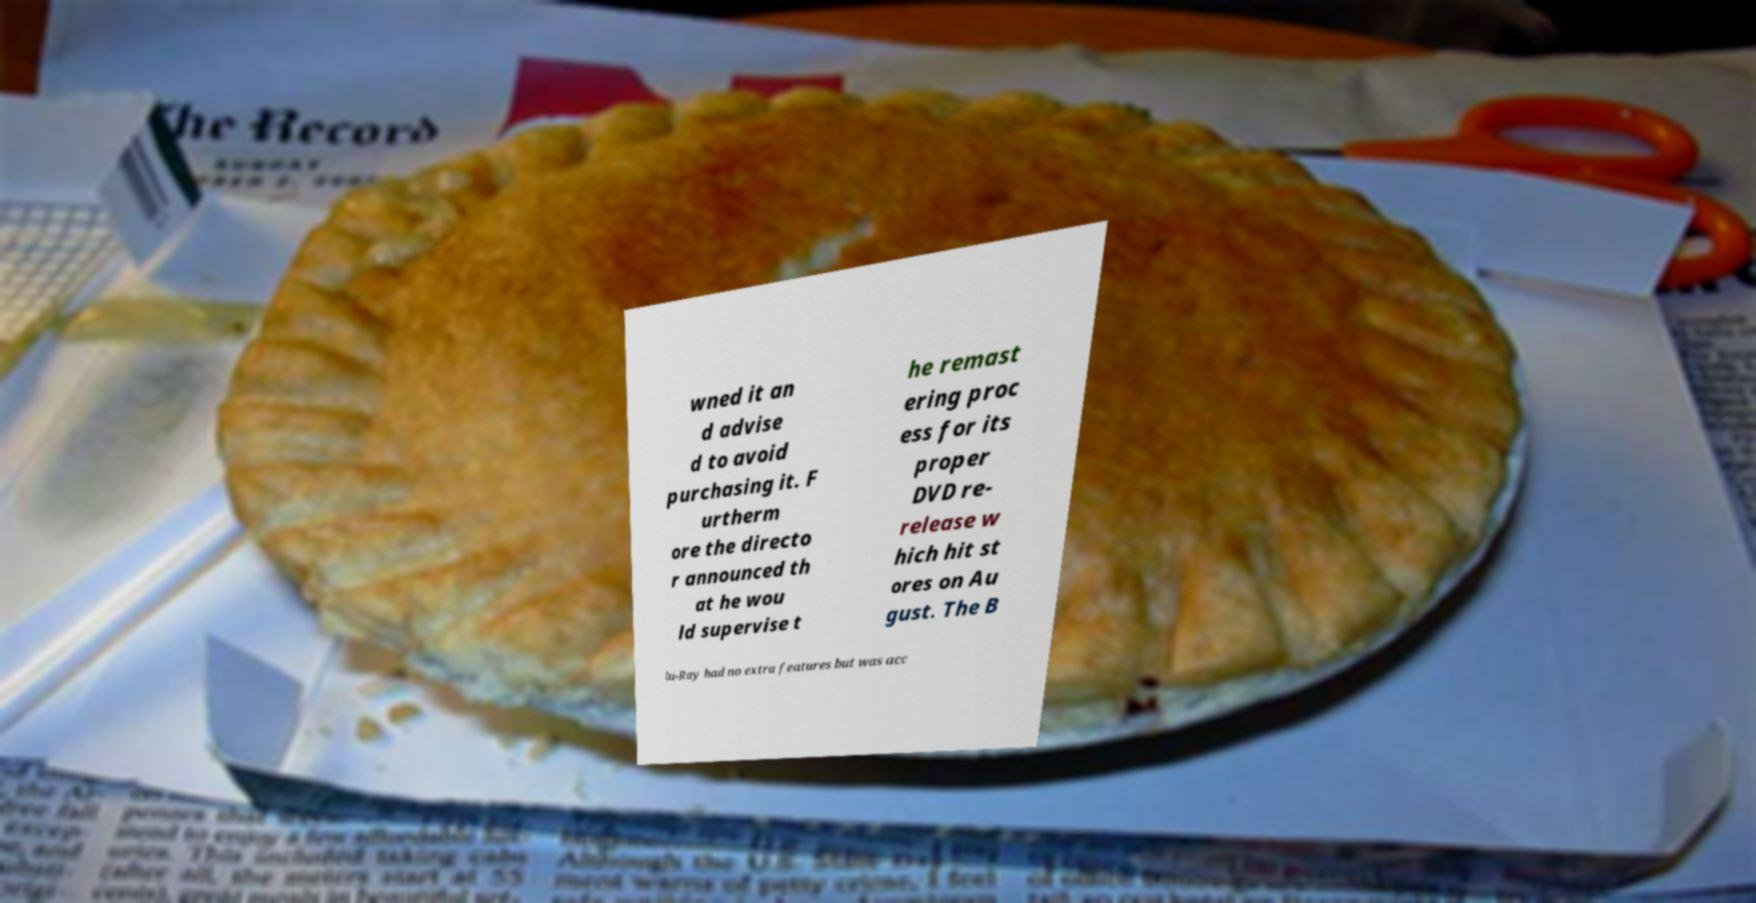There's text embedded in this image that I need extracted. Can you transcribe it verbatim? wned it an d advise d to avoid purchasing it. F urtherm ore the directo r announced th at he wou ld supervise t he remast ering proc ess for its proper DVD re- release w hich hit st ores on Au gust. The B lu-Ray had no extra features but was acc 